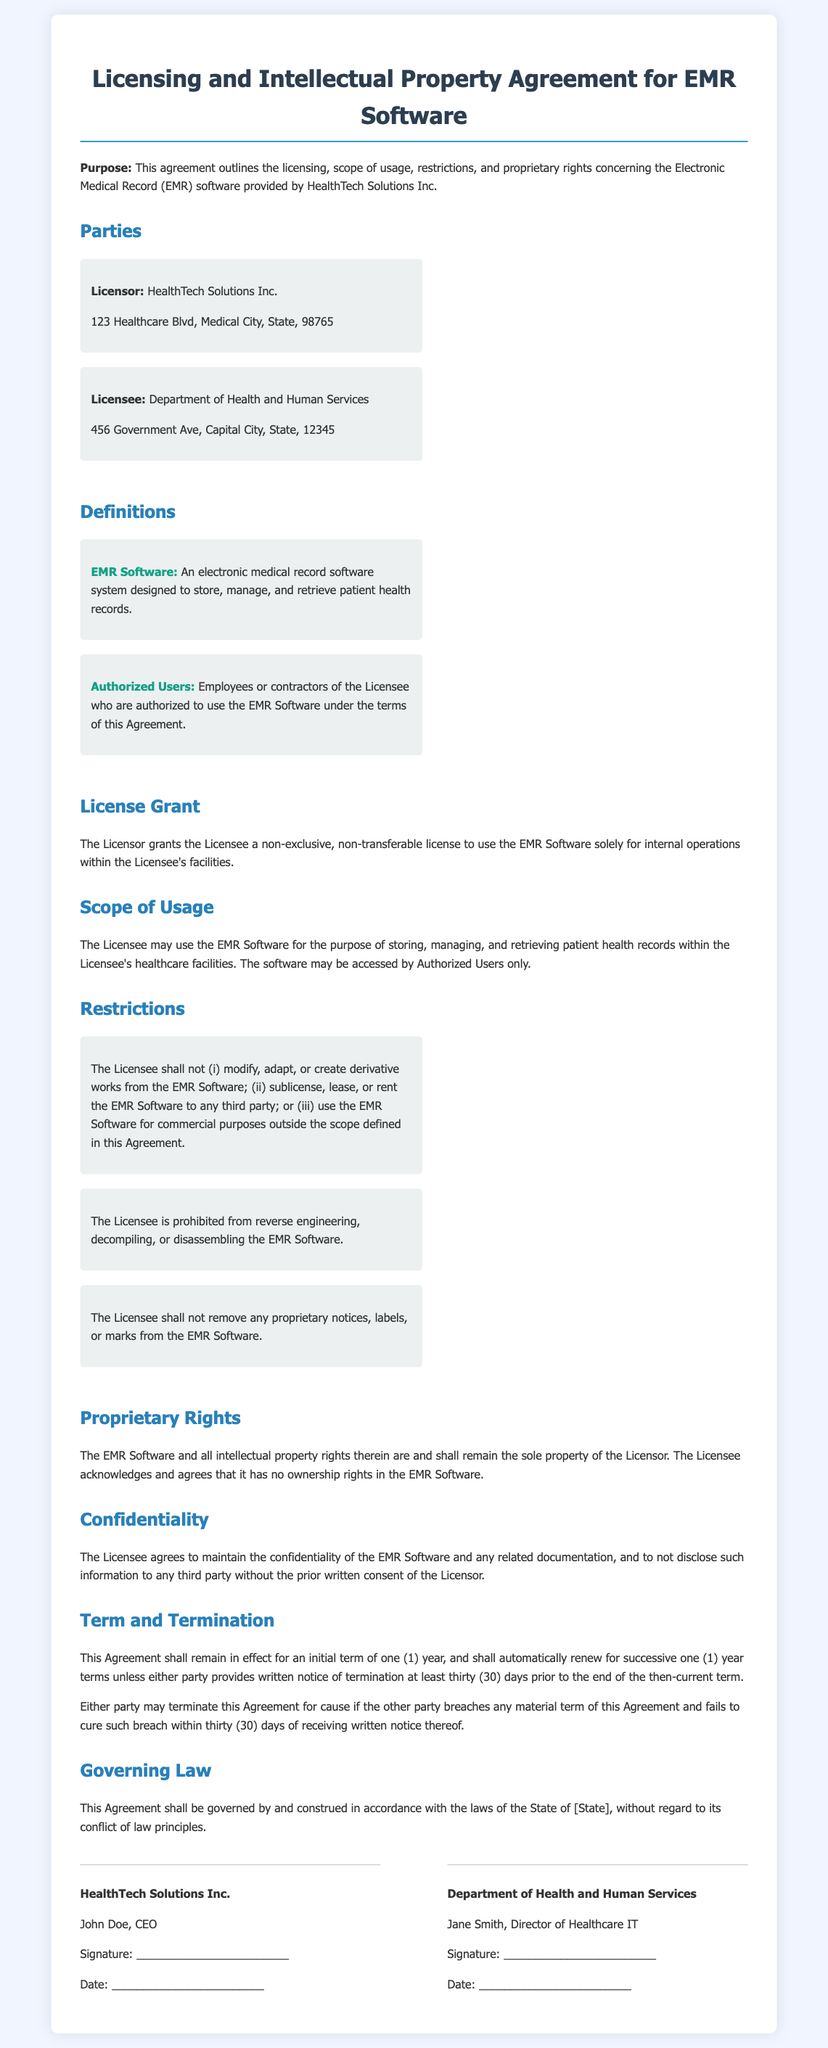What is the name of the Licensor? The Licensor is identified as HealthTech Solutions Inc. in the document.
Answer: HealthTech Solutions Inc What is the initial term of the Agreement? The document states that the initial term of the Agreement is one (1) year.
Answer: one (1) year Who is the Director of Healthcare IT for the Licensee? The document names Jane Smith as the Director of Healthcare IT for the Licensee.
Answer: Jane Smith What should be maintained according to the Confidentiality clause? The Licensee agrees to maintain the confidentiality of the EMR Software and any related documentation.
Answer: confidentiality What actions are prohibited under the Restrictions section? The Licensee is prohibited from modifying, sublicensing, reverse engineering, and removing proprietary notices from the EMR Software.
Answer: modifying, sublicensing, reverse engineering, removing proprietary notices What are the governing laws stated in the Agreement? The governing laws mentioned in the Agreement are those of the State of [State].
Answer: State of [State] How many days' notice is required for termination? The document specifies that a written notice of termination must be provided at least thirty (30) days prior to the end of the term.
Answer: thirty (30) days What type of license is granted to the Licensee? The document states that a non-exclusive, non-transferable license is granted to the Licensee.
Answer: non-exclusive, non-transferable What rights do the Licensee have in the EMR Software? The Licensee acknowledges that it has no ownership rights in the EMR Software.
Answer: no ownership rights 